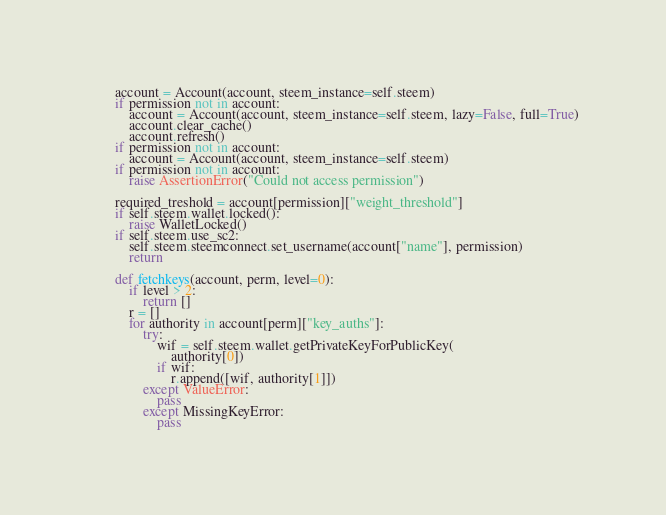<code> <loc_0><loc_0><loc_500><loc_500><_Python_>        account = Account(account, steem_instance=self.steem)
        if permission not in account:
            account = Account(account, steem_instance=self.steem, lazy=False, full=True)
            account.clear_cache()
            account.refresh()
        if permission not in account:
            account = Account(account, steem_instance=self.steem)
        if permission not in account:
            raise AssertionError("Could not access permission")

        required_treshold = account[permission]["weight_threshold"]
        if self.steem.wallet.locked():
            raise WalletLocked()
        if self.steem.use_sc2:
            self.steem.steemconnect.set_username(account["name"], permission)
            return

        def fetchkeys(account, perm, level=0):
            if level > 2:
                return []
            r = []
            for authority in account[perm]["key_auths"]:
                try:
                    wif = self.steem.wallet.getPrivateKeyForPublicKey(
                        authority[0])
                    if wif:
                        r.append([wif, authority[1]])
                except ValueError:
                    pass
                except MissingKeyError:
                    pass
</code> 